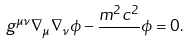Convert formula to latex. <formula><loc_0><loc_0><loc_500><loc_500>g ^ { \mu \nu } \nabla _ { \mu } \nabla _ { \nu } \phi - \frac { m ^ { 2 } c ^ { 2 } } { } \phi = 0 .</formula> 